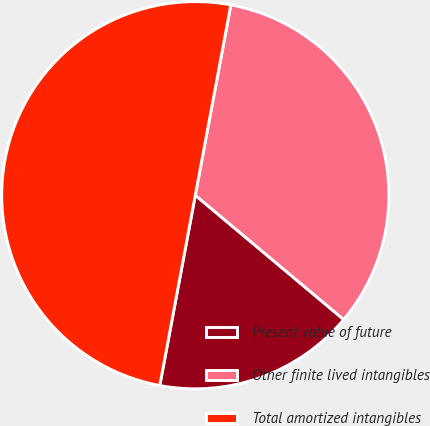<chart> <loc_0><loc_0><loc_500><loc_500><pie_chart><fcel>Present value of future<fcel>Other finite lived intangibles<fcel>Total amortized intangibles<nl><fcel>16.84%<fcel>33.16%<fcel>50.0%<nl></chart> 